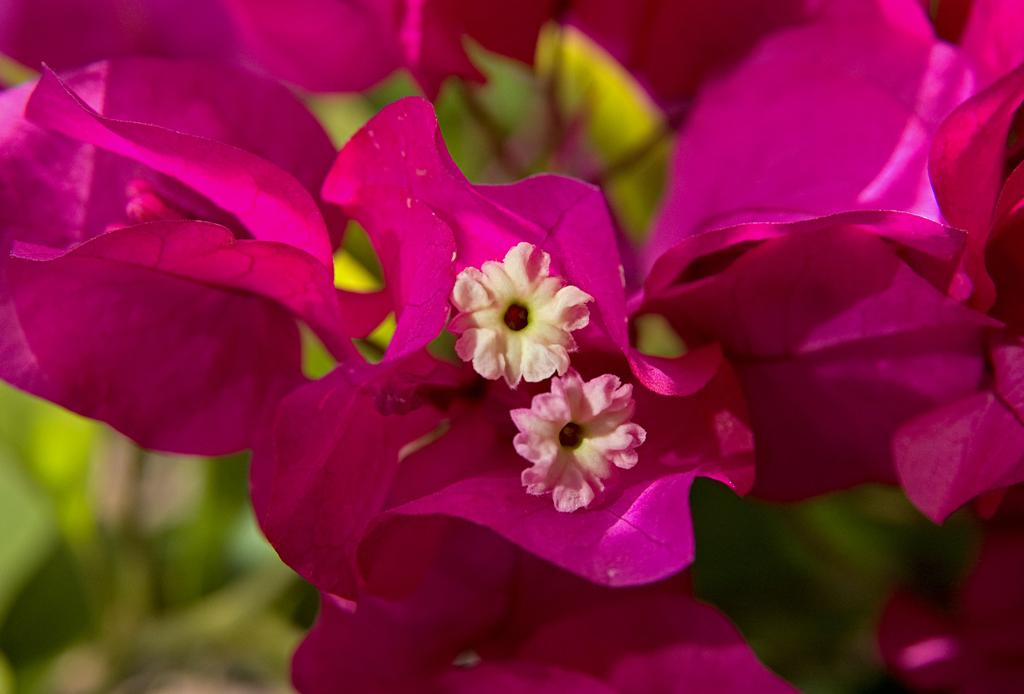What is the main subject of the image? The main subject of the image is flowers. Where are the flowers located in the image? The flowers are in the center of the image. What color are the flowers? The flowers are pink in color. What type of blade can be seen cutting the flowers in the image? There is no blade or cutting action depicted in the image; the flowers are simply displayed in the center. 